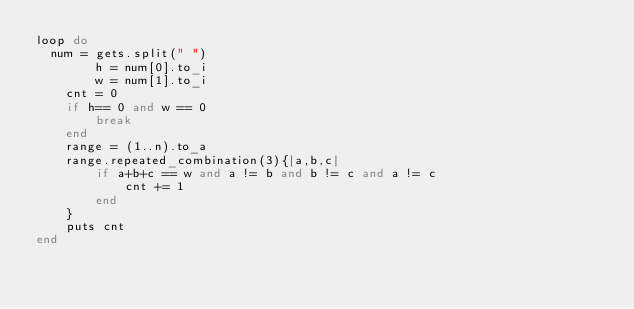<code> <loc_0><loc_0><loc_500><loc_500><_Ruby_>loop do
  num = gets.split(" ")
        h = num[0].to_i
        w = num[1].to_i
    cnt = 0
    if h== 0 and w == 0
        break
    end
    range = (1..n).to_a
    range.repeated_combination(3){|a,b,c|
        if a+b+c == w and a != b and b != c and a != c
            cnt += 1
        end
    }
    puts cnt
end</code> 